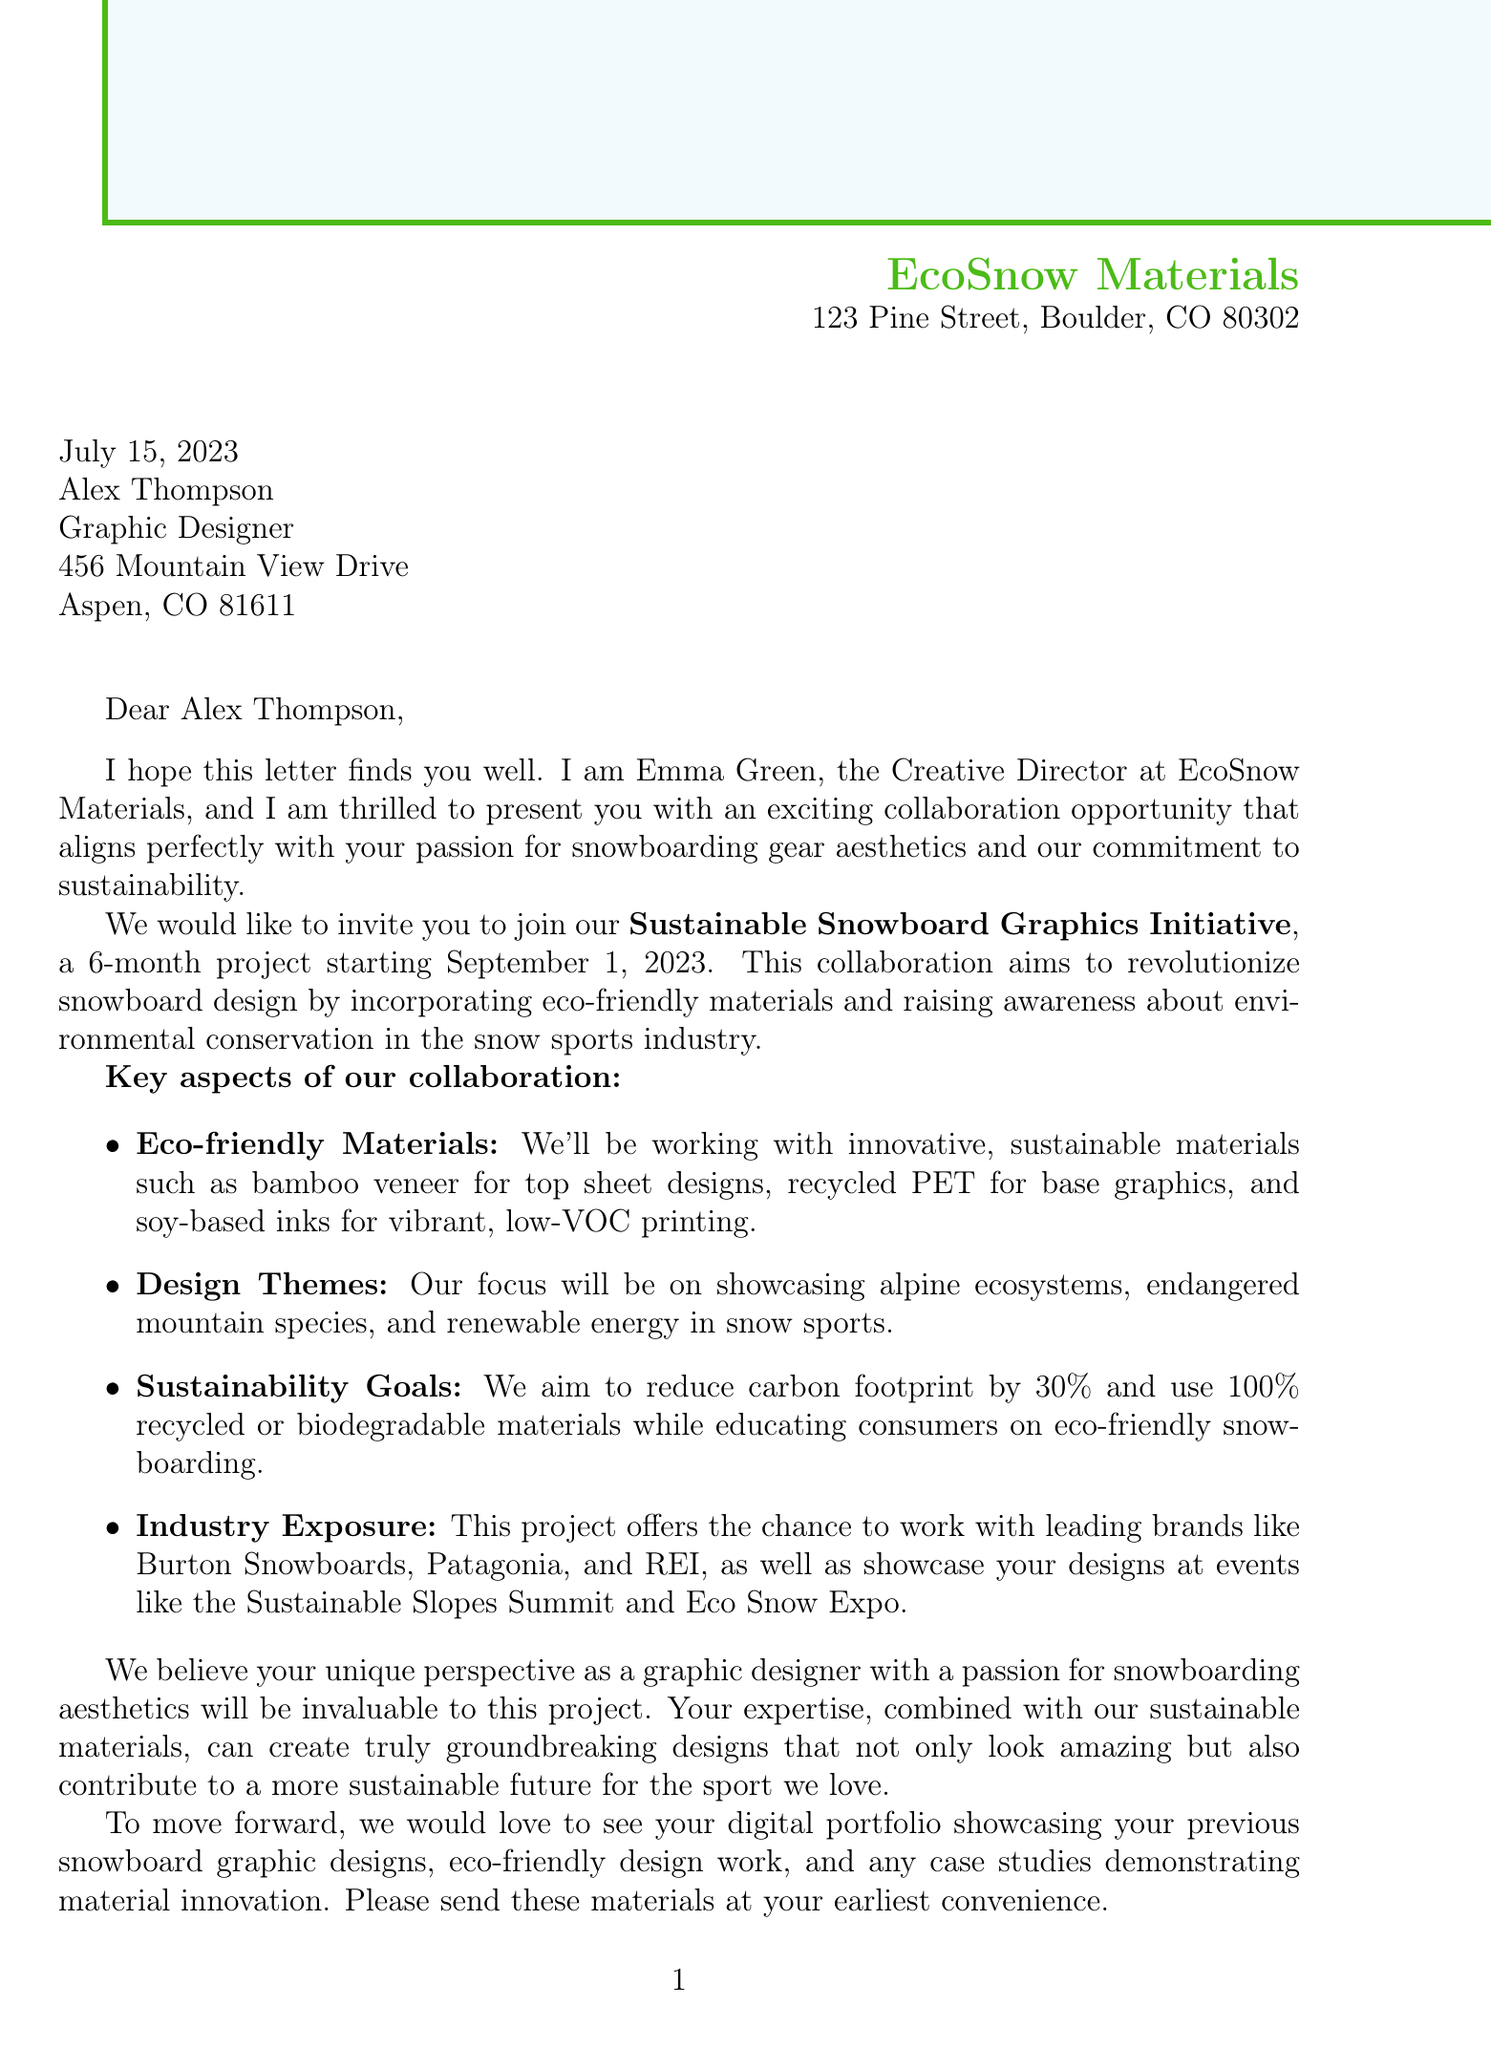What is the name of the project? The project is referred to as the "Sustainable Snowboard Graphics Initiative."
Answer: Sustainable Snowboard Graphics Initiative Who is the sender of the letter? The sender of the letter is identified as Emma Green, the Creative Director at EcoSnow Materials.
Answer: Emma Green What is the duration of the project? The duration of the project is specified as 6 months.
Answer: 6 months When does the project start? The start date of the project is mentioned as September 1, 2023.
Answer: September 1, 2023 What are the three materials mentioned for eco-friendly graphics? The document lists bamboo veneer, recycled PET, and soy-based inks as eco-friendly materials.
Answer: Bamboo veneer, recycled PET, and soy-based inks How much does EcoSnow Materials aim to reduce the carbon footprint? The goal specified is to reduce the carbon footprint by 30%.
Answer: 30% Which three design themes are emphasized in the collaboration? The design themes to be focused on include alpine ecosystems, endangered mountain species, and renewable energy in snow sports.
Answer: Alpine ecosystems, endangered mountain species, renewable energy in snow sports What is required for the portfolio submission? The portfolio submission must include previous snowboard graphic designs, examples of eco-friendly design work, and case studies showcasing material innovation.
Answer: Digital portfolio (PDF or website) What is the name of the sender's company? The company of the sender, Emma Green, is EcoSnow Materials.
Answer: EcoSnow Materials 